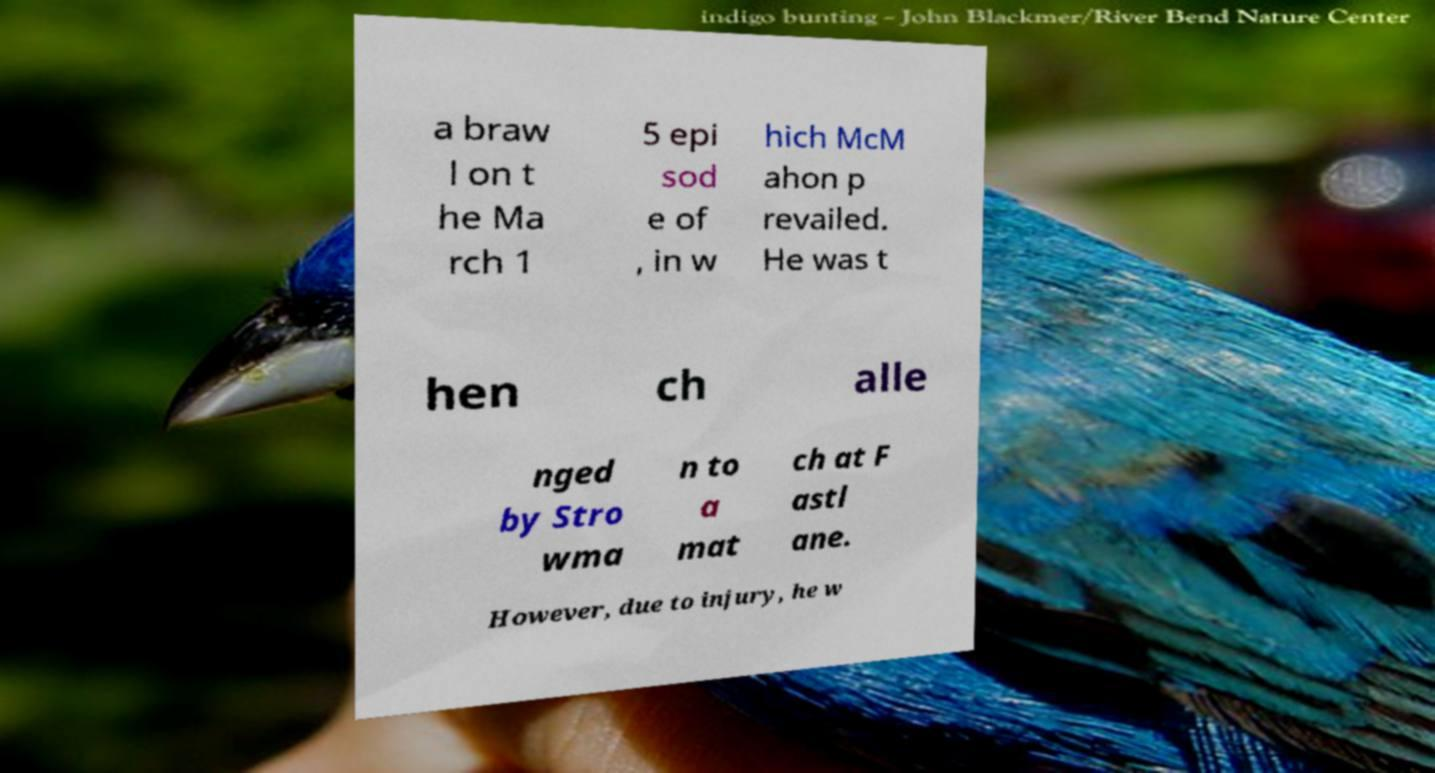I need the written content from this picture converted into text. Can you do that? a braw l on t he Ma rch 1 5 epi sod e of , in w hich McM ahon p revailed. He was t hen ch alle nged by Stro wma n to a mat ch at F astl ane. However, due to injury, he w 